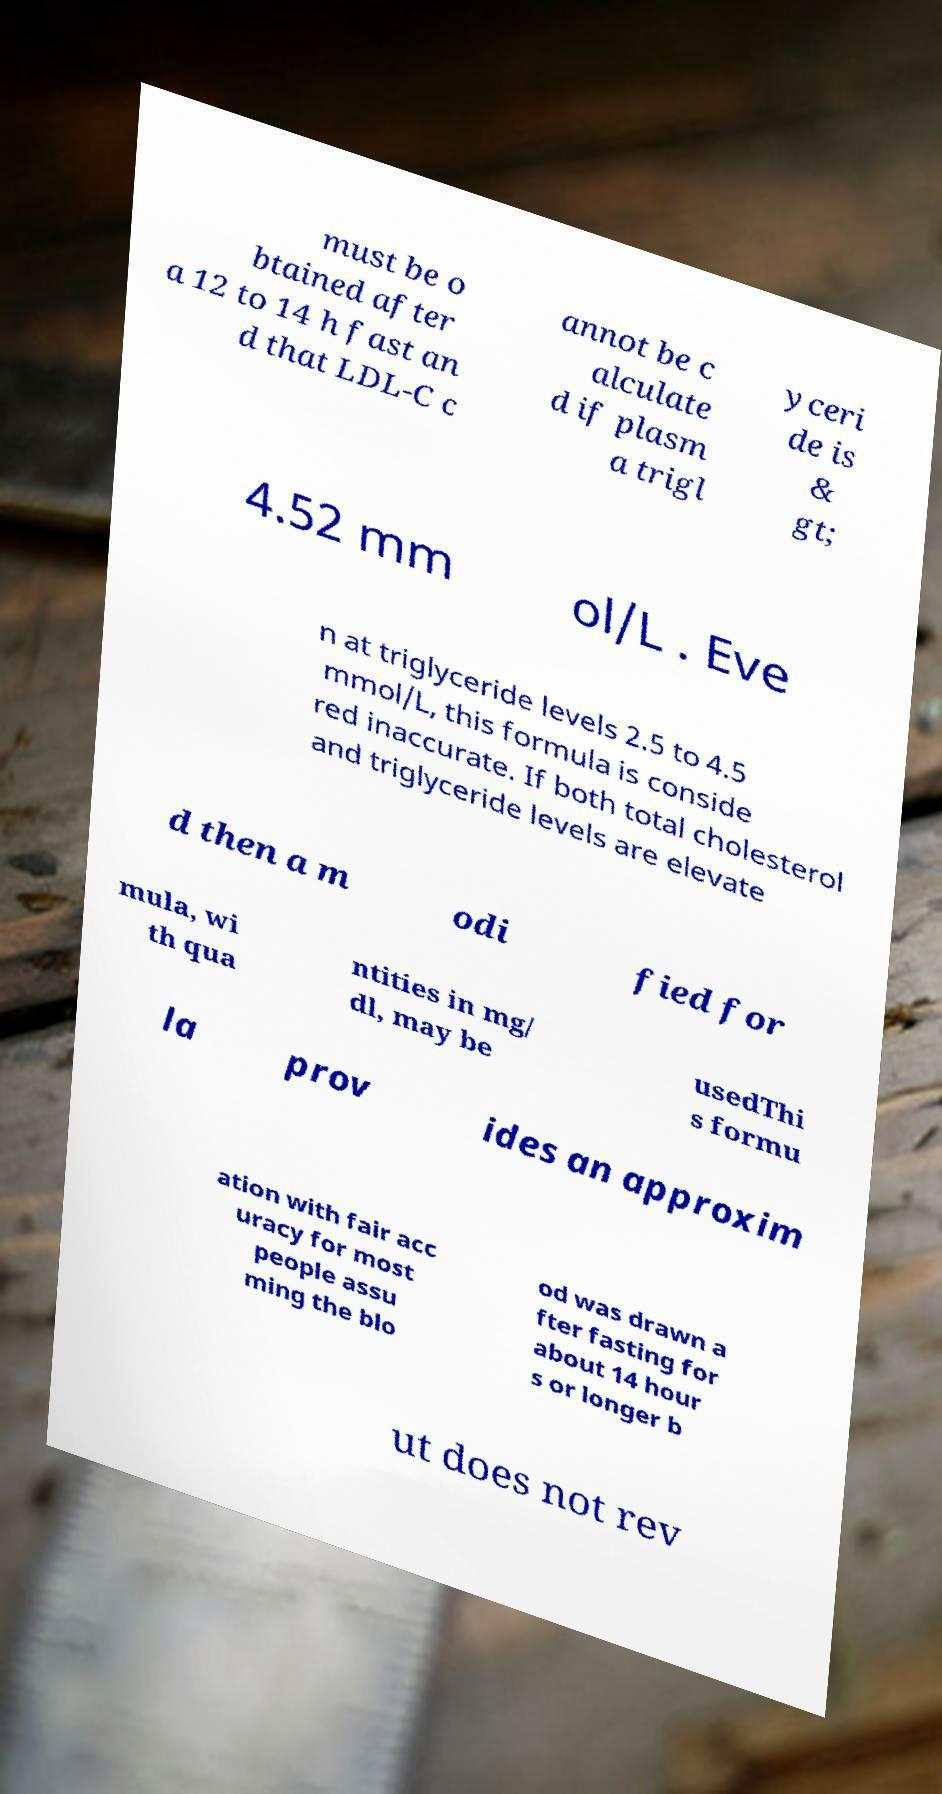Can you accurately transcribe the text from the provided image for me? must be o btained after a 12 to 14 h fast an d that LDL-C c annot be c alculate d if plasm a trigl yceri de is & gt; 4.52 mm ol/L . Eve n at triglyceride levels 2.5 to 4.5 mmol/L, this formula is conside red inaccurate. If both total cholesterol and triglyceride levels are elevate d then a m odi fied for mula, wi th qua ntities in mg/ dl, may be usedThi s formu la prov ides an approxim ation with fair acc uracy for most people assu ming the blo od was drawn a fter fasting for about 14 hour s or longer b ut does not rev 